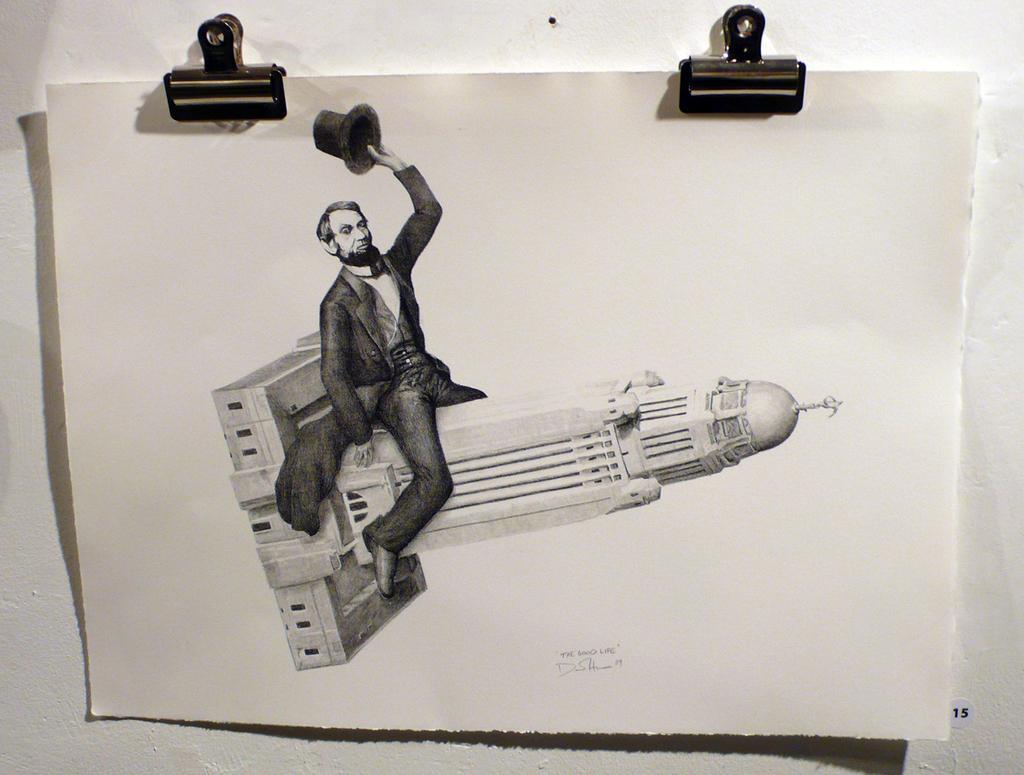Please provide a concise description of this image. In this image there is a paper with an art of a man holding a hat in his hand and sitting on the building. The paper is hanging on the wall with the help of paper clips. 